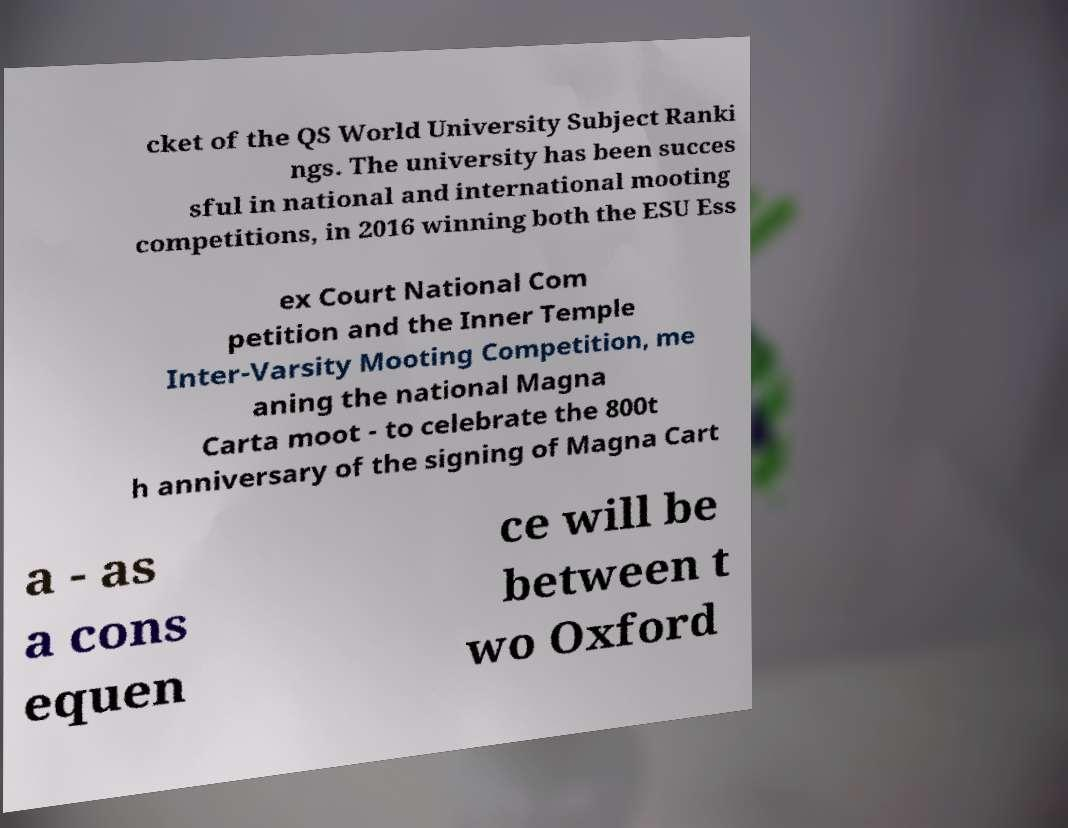Please read and relay the text visible in this image. What does it say? cket of the QS World University Subject Ranki ngs. The university has been succes sful in national and international mooting competitions, in 2016 winning both the ESU Ess ex Court National Com petition and the Inner Temple Inter-Varsity Mooting Competition, me aning the national Magna Carta moot - to celebrate the 800t h anniversary of the signing of Magna Cart a - as a cons equen ce will be between t wo Oxford 